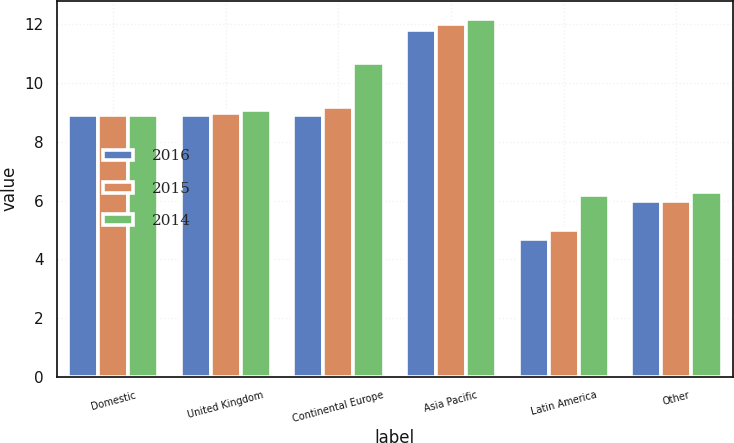Convert chart to OTSL. <chart><loc_0><loc_0><loc_500><loc_500><stacked_bar_chart><ecel><fcel>Domestic<fcel>United Kingdom<fcel>Continental Europe<fcel>Asia Pacific<fcel>Latin America<fcel>Other<nl><fcel>2016<fcel>8.9<fcel>8.9<fcel>8.9<fcel>11.8<fcel>4.7<fcel>6<nl><fcel>2015<fcel>8.9<fcel>9<fcel>9.2<fcel>12<fcel>5<fcel>6<nl><fcel>2014<fcel>8.9<fcel>9.1<fcel>10.7<fcel>12.2<fcel>6.2<fcel>6.3<nl></chart> 